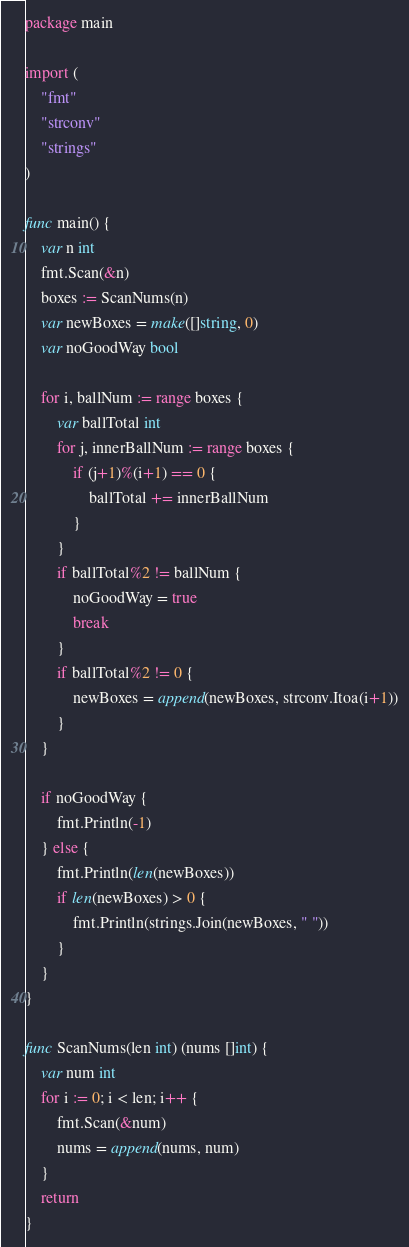Convert code to text. <code><loc_0><loc_0><loc_500><loc_500><_Go_>package main

import (
	"fmt"
	"strconv"
	"strings"
)

func main() {
	var n int
	fmt.Scan(&n)
	boxes := ScanNums(n)
	var newBoxes = make([]string, 0)
	var noGoodWay bool

	for i, ballNum := range boxes {
		var ballTotal int
		for j, innerBallNum := range boxes {
			if (j+1)%(i+1) == 0 {
				ballTotal += innerBallNum
			}
		}
		if ballTotal%2 != ballNum {
			noGoodWay = true
			break
		}
		if ballTotal%2 != 0 {
			newBoxes = append(newBoxes, strconv.Itoa(i+1))
		}
	}

	if noGoodWay {
		fmt.Println(-1)
	} else {
		fmt.Println(len(newBoxes))
		if len(newBoxes) > 0 {
			fmt.Println(strings.Join(newBoxes, " "))
		}
	}
}

func ScanNums(len int) (nums []int) {
	var num int
	for i := 0; i < len; i++ {
		fmt.Scan(&num)
		nums = append(nums, num)
	}
	return
}
</code> 